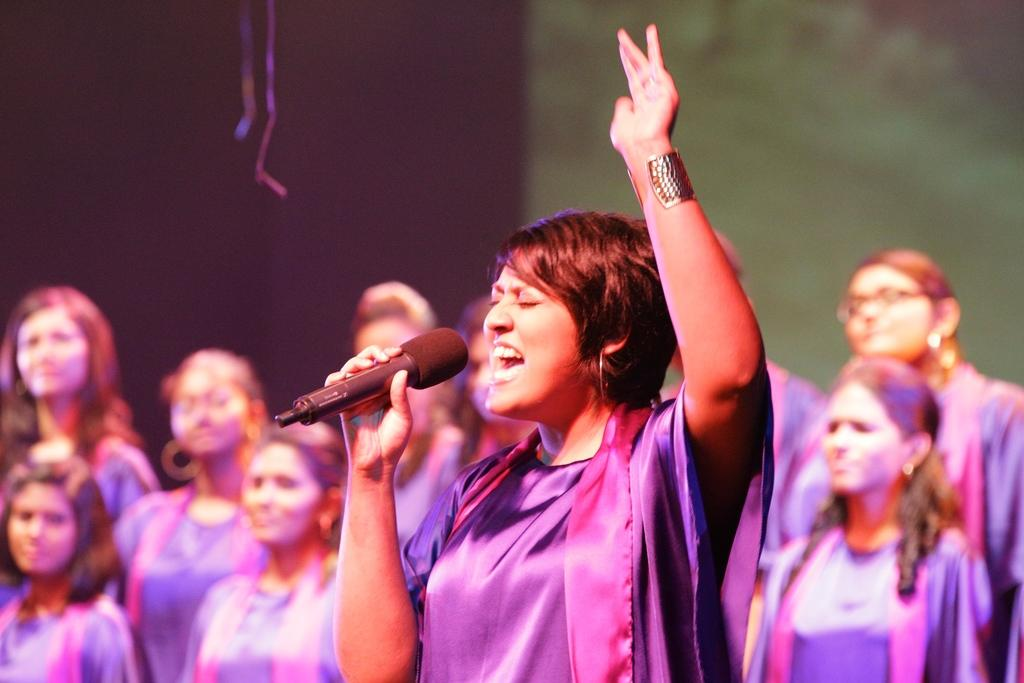What is happening in the image? There is a group of people in the image, and a woman is holding a microphone. What is the woman doing with the microphone? The woman is singing. What type of caption is written on the microphone in the image? There is no caption written on the microphone in the image. How much tax is being paid by the woman in the image? There is no information about tax in the image. 